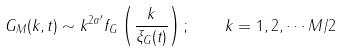Convert formula to latex. <formula><loc_0><loc_0><loc_500><loc_500>G _ { M } ( k , t ) \sim k ^ { 2 \alpha ^ { \prime } } f _ { G } \left ( \frac { k } { \xi _ { G } ( t ) } \right ) ; \quad k = 1 , 2 , \cdots M / 2</formula> 